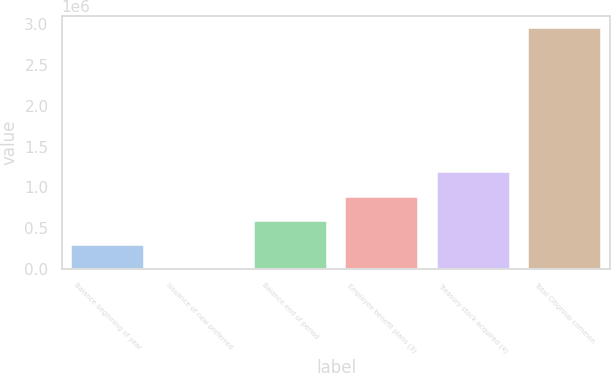Convert chart. <chart><loc_0><loc_0><loc_500><loc_500><bar_chart><fcel>Balance beginning of year<fcel>Issuance of new preferred<fcel>Balance end of period<fcel>Employee benefit plans (3)<fcel>Treasury stock acquired (4)<fcel>Total Citigroup common<nl><fcel>295553<fcel>250<fcel>590856<fcel>886159<fcel>1.18146e+06<fcel>2.95328e+06<nl></chart> 